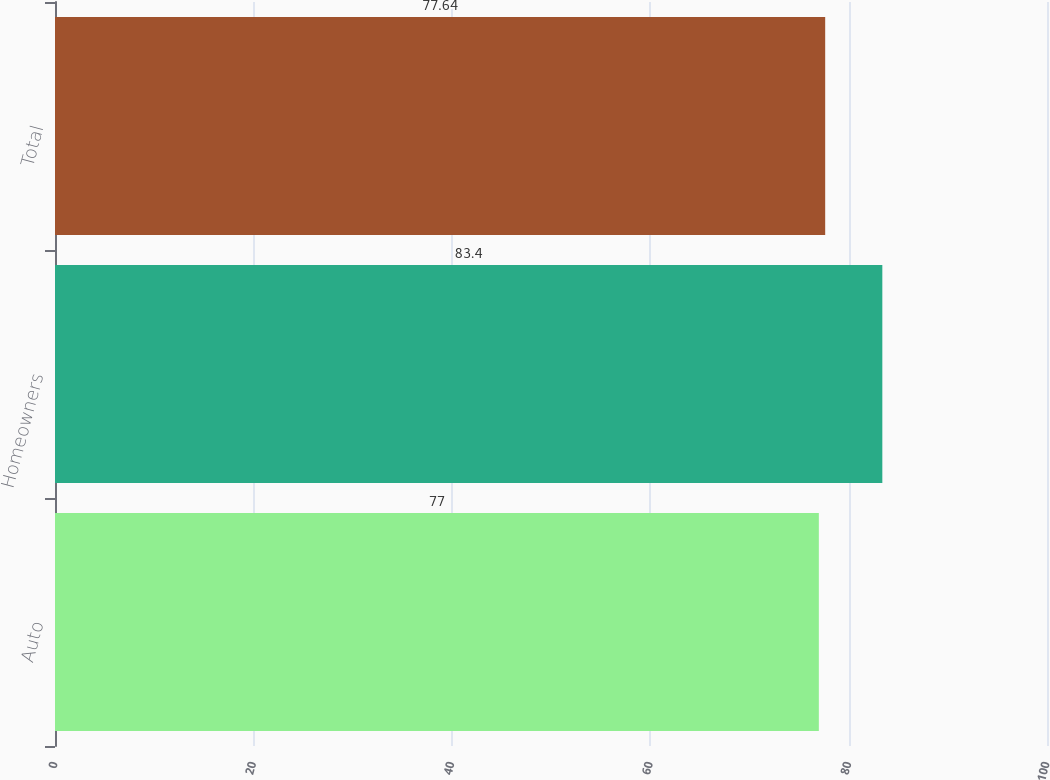<chart> <loc_0><loc_0><loc_500><loc_500><bar_chart><fcel>Auto<fcel>Homeowners<fcel>Total<nl><fcel>77<fcel>83.4<fcel>77.64<nl></chart> 